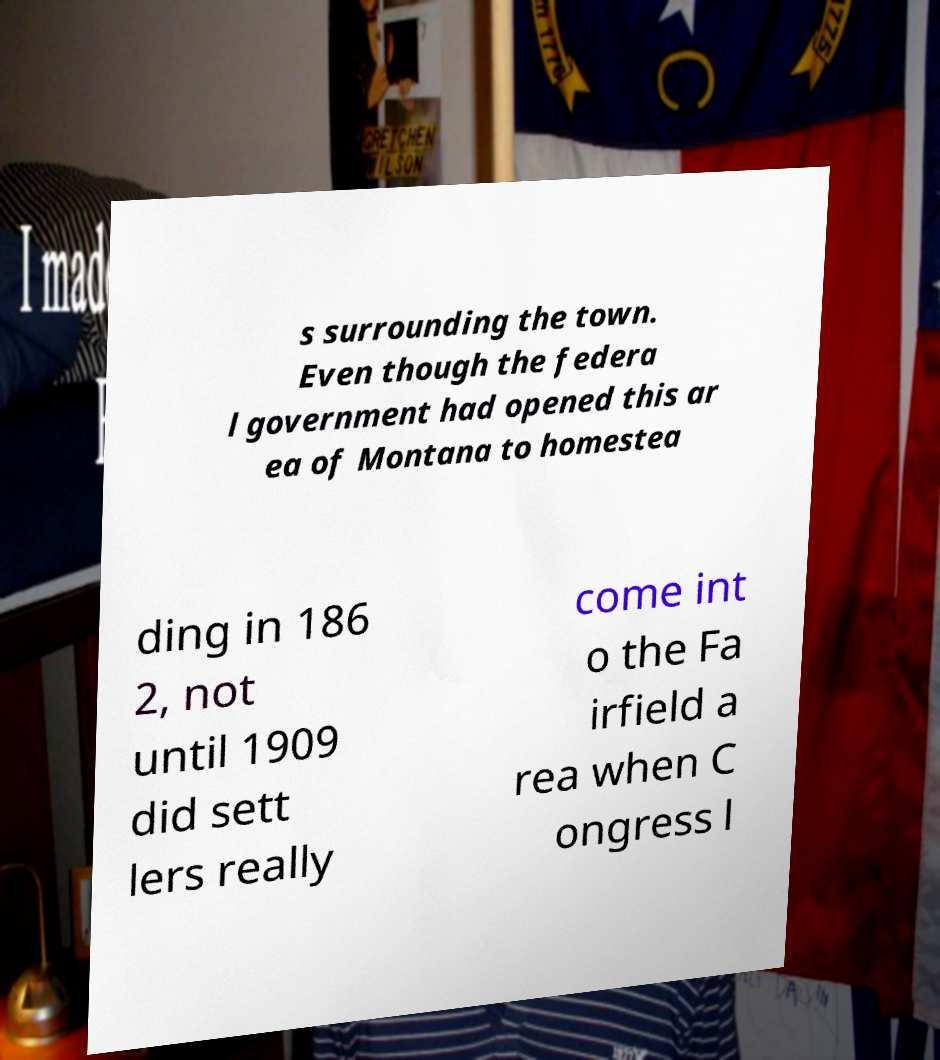Please read and relay the text visible in this image. What does it say? s surrounding the town. Even though the federa l government had opened this ar ea of Montana to homestea ding in 186 2, not until 1909 did sett lers really come int o the Fa irfield a rea when C ongress l 